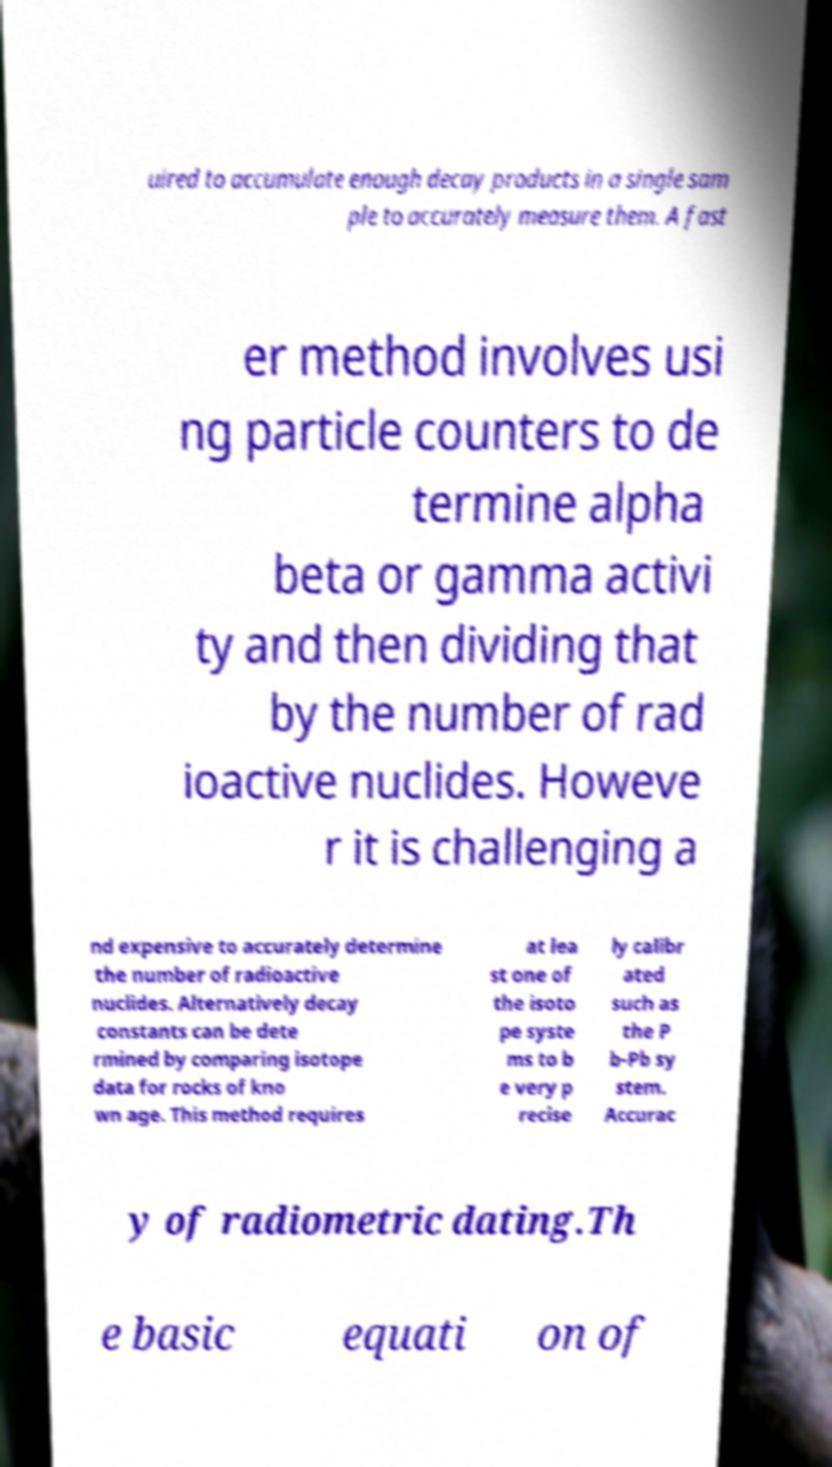There's text embedded in this image that I need extracted. Can you transcribe it verbatim? uired to accumulate enough decay products in a single sam ple to accurately measure them. A fast er method involves usi ng particle counters to de termine alpha beta or gamma activi ty and then dividing that by the number of rad ioactive nuclides. Howeve r it is challenging a nd expensive to accurately determine the number of radioactive nuclides. Alternatively decay constants can be dete rmined by comparing isotope data for rocks of kno wn age. This method requires at lea st one of the isoto pe syste ms to b e very p recise ly calibr ated such as the P b-Pb sy stem. Accurac y of radiometric dating.Th e basic equati on of 